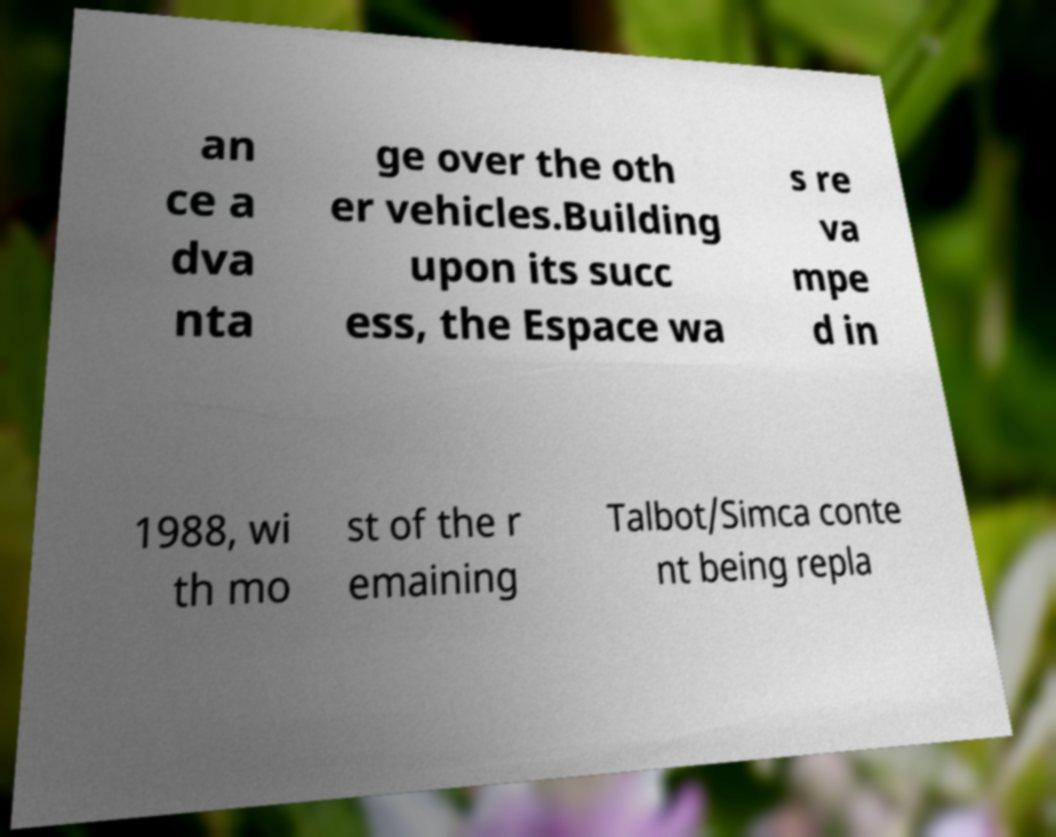I need the written content from this picture converted into text. Can you do that? an ce a dva nta ge over the oth er vehicles.Building upon its succ ess, the Espace wa s re va mpe d in 1988, wi th mo st of the r emaining Talbot/Simca conte nt being repla 